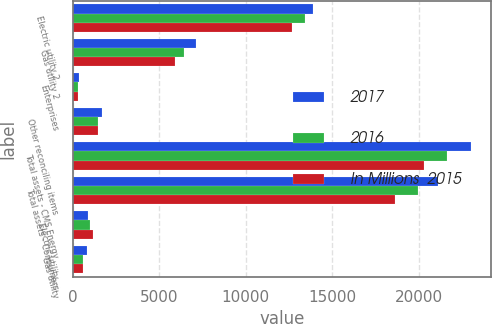<chart> <loc_0><loc_0><loc_500><loc_500><stacked_bar_chart><ecel><fcel>Electric utility 2<fcel>Gas utility 2<fcel>Enterprises<fcel>Other reconciling items<fcel>Total assets - CMS Energy<fcel>Total assets - Consumers<fcel>Electric utility<fcel>Gas utility<nl><fcel>2017<fcel>13906<fcel>7139<fcel>342<fcel>1663<fcel>23050<fcel>21099<fcel>882<fcel>800<nl><fcel>2016<fcel>13429<fcel>6446<fcel>269<fcel>1478<fcel>21622<fcel>19946<fcel>1007<fcel>611<nl><fcel>In Millions  2015<fcel>12660<fcel>5912<fcel>270<fcel>1457<fcel>20299<fcel>18635<fcel>1136<fcel>558<nl></chart> 